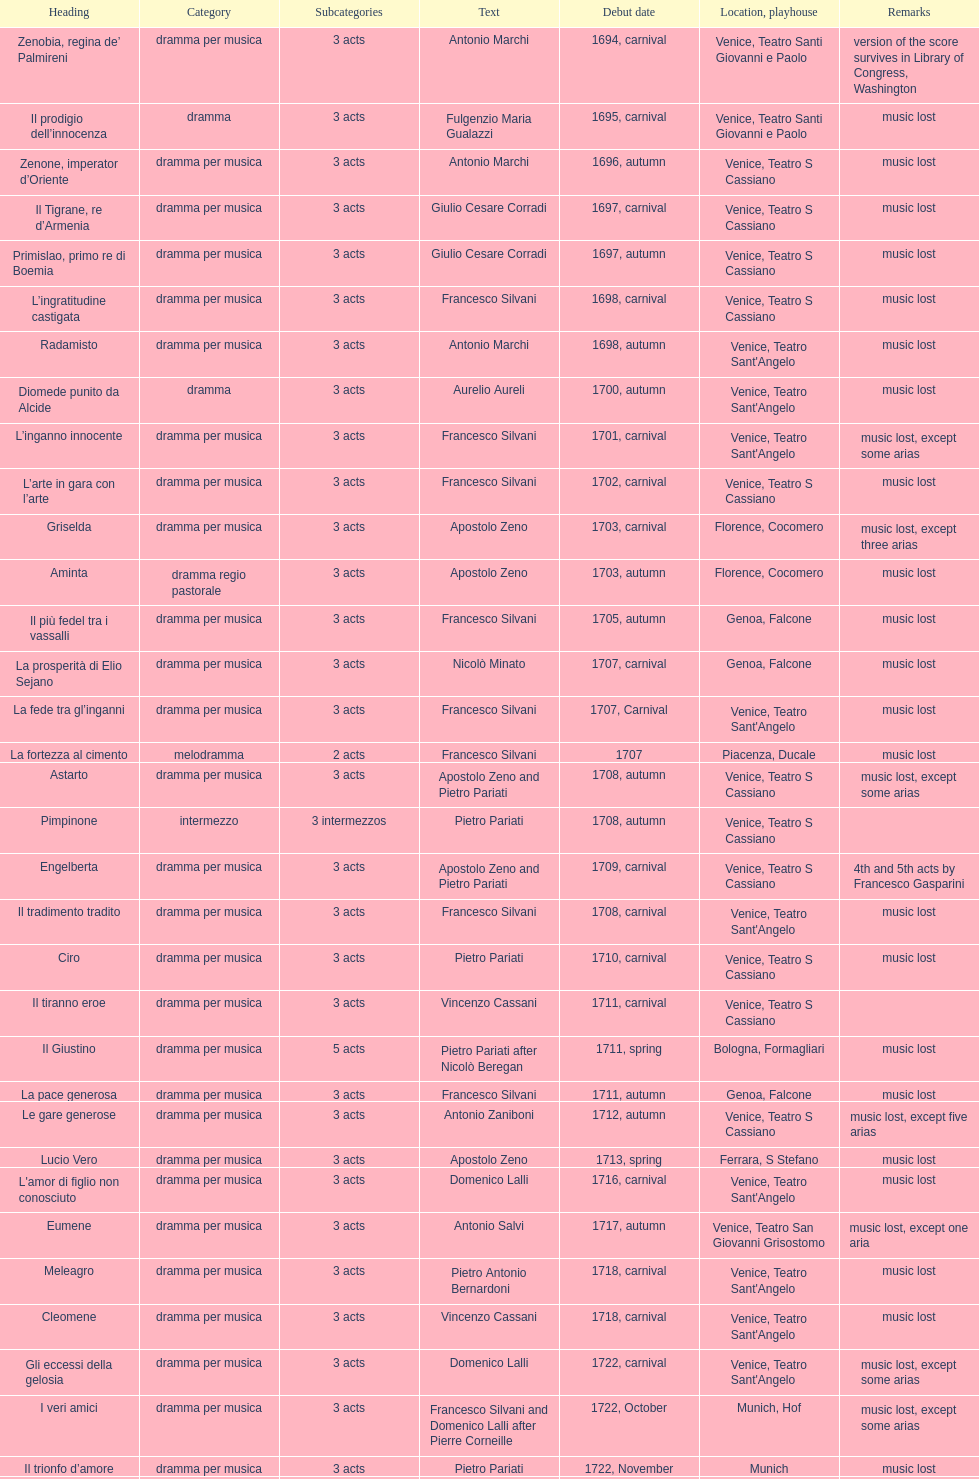How many operas on this list has at least 3 acts? 51. 